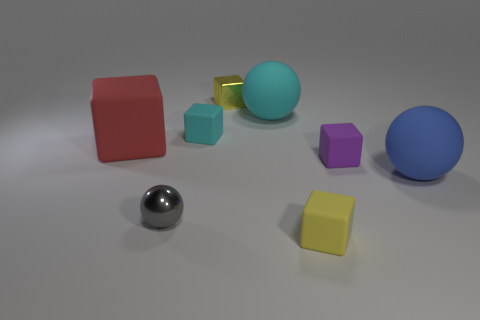Subtract 1 cubes. How many cubes are left? 4 Subtract all big red rubber cubes. How many cubes are left? 4 Subtract all brown cubes. Subtract all cyan balls. How many cubes are left? 5 Add 1 small green rubber things. How many objects exist? 9 Subtract all balls. How many objects are left? 5 Add 5 blue things. How many blue things are left? 6 Add 8 large balls. How many large balls exist? 10 Subtract 0 purple cylinders. How many objects are left? 8 Subtract all tiny yellow matte blocks. Subtract all cyan objects. How many objects are left? 5 